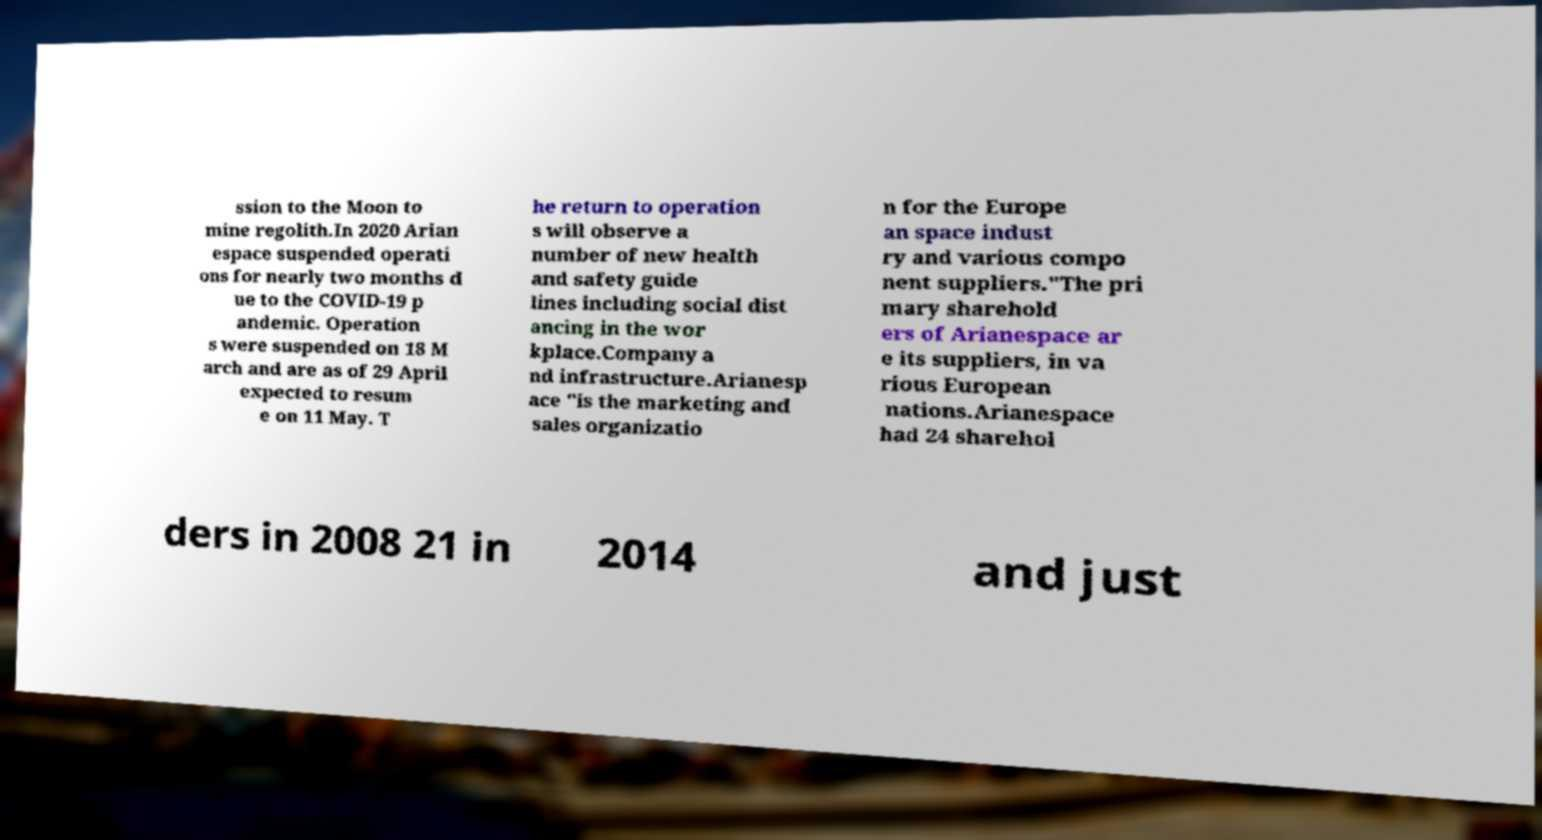For documentation purposes, I need the text within this image transcribed. Could you provide that? ssion to the Moon to mine regolith.In 2020 Arian espace suspended operati ons for nearly two months d ue to the COVID-19 p andemic. Operation s were suspended on 18 M arch and are as of 29 April expected to resum e on 11 May. T he return to operation s will observe a number of new health and safety guide lines including social dist ancing in the wor kplace.Company a nd infrastructure.Arianesp ace "is the marketing and sales organizatio n for the Europe an space indust ry and various compo nent suppliers."The pri mary sharehold ers of Arianespace ar e its suppliers, in va rious European nations.Arianespace had 24 sharehol ders in 2008 21 in 2014 and just 